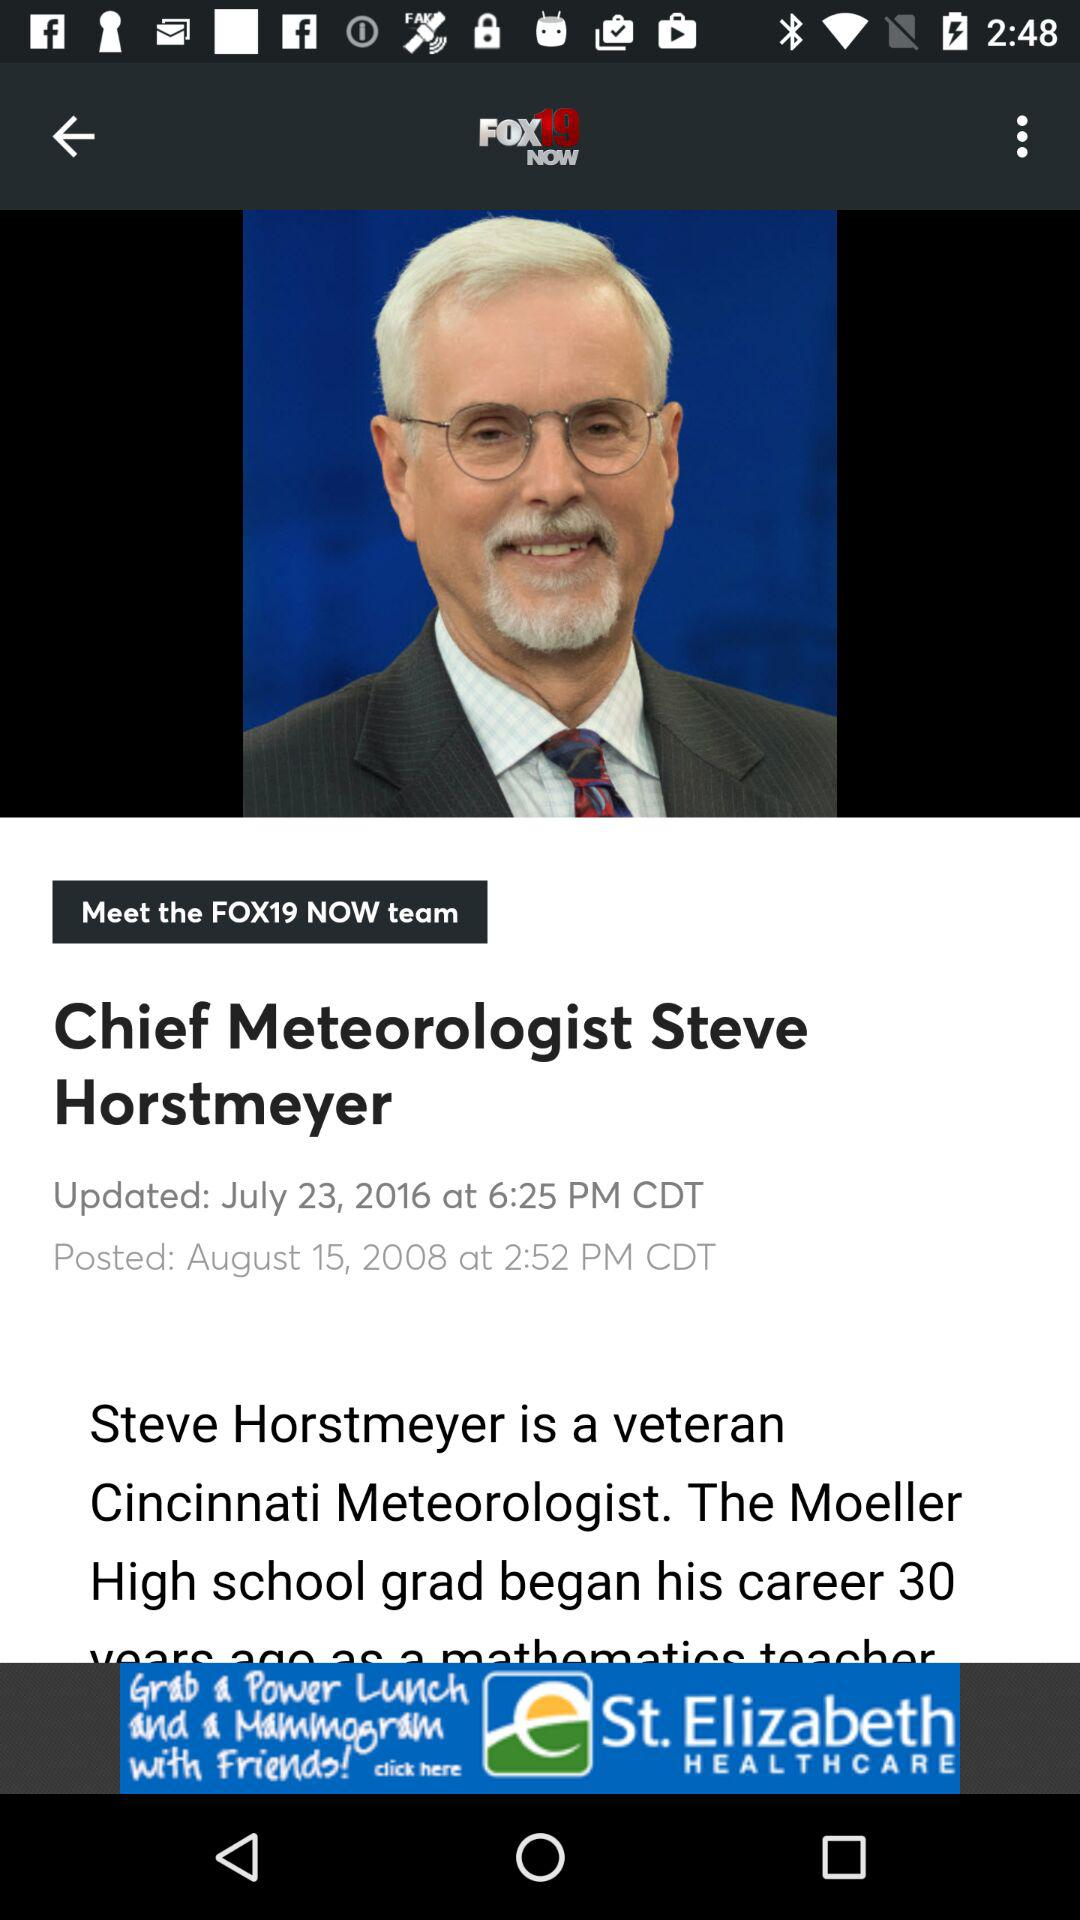On which date was the news "Chief Meteorologist Steve Horstmeyer" last updated? The news "Chief Meteorologist Steve Horstmeyer" was last updated on July 23, 2016. 